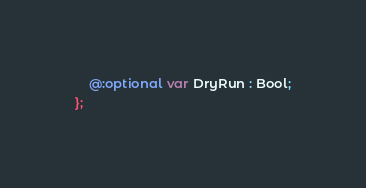Convert code to text. <code><loc_0><loc_0><loc_500><loc_500><_Haxe_>    @:optional var DryRun : Bool;
};
</code> 